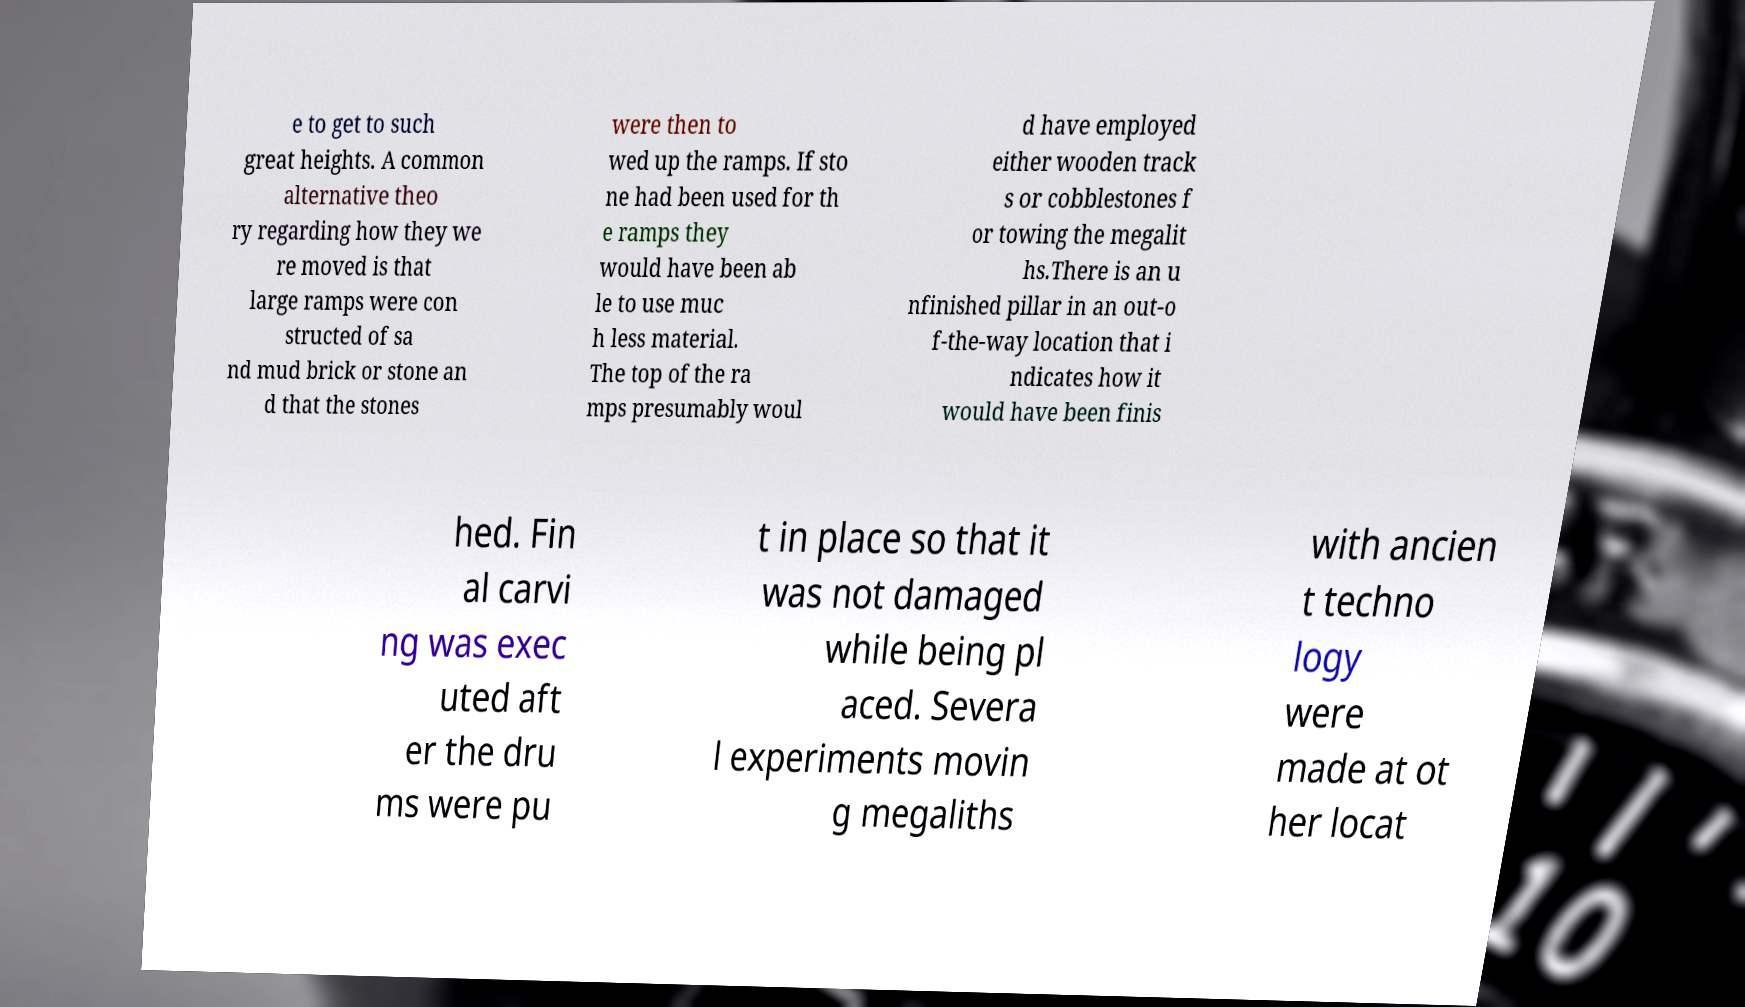What messages or text are displayed in this image? I need them in a readable, typed format. e to get to such great heights. A common alternative theo ry regarding how they we re moved is that large ramps were con structed of sa nd mud brick or stone an d that the stones were then to wed up the ramps. If sto ne had been used for th e ramps they would have been ab le to use muc h less material. The top of the ra mps presumably woul d have employed either wooden track s or cobblestones f or towing the megalit hs.There is an u nfinished pillar in an out-o f-the-way location that i ndicates how it would have been finis hed. Fin al carvi ng was exec uted aft er the dru ms were pu t in place so that it was not damaged while being pl aced. Severa l experiments movin g megaliths with ancien t techno logy were made at ot her locat 